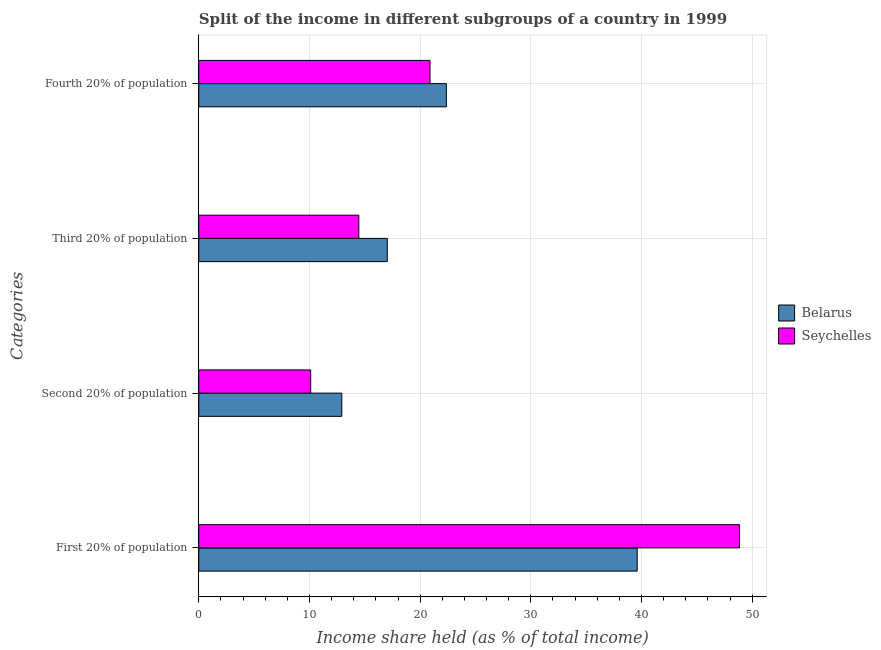Are the number of bars on each tick of the Y-axis equal?
Your response must be concise. Yes. How many bars are there on the 2nd tick from the bottom?
Give a very brief answer. 2. What is the label of the 1st group of bars from the top?
Give a very brief answer. Fourth 20% of population. What is the share of the income held by second 20% of the population in Belarus?
Offer a very short reply. 12.92. Across all countries, what is the maximum share of the income held by fourth 20% of the population?
Your answer should be very brief. 22.37. Across all countries, what is the minimum share of the income held by third 20% of the population?
Your response must be concise. 14.46. In which country was the share of the income held by first 20% of the population maximum?
Make the answer very short. Seychelles. In which country was the share of the income held by first 20% of the population minimum?
Ensure brevity in your answer.  Belarus. What is the total share of the income held by first 20% of the population in the graph?
Offer a terse response. 88.47. What is the difference between the share of the income held by second 20% of the population in Seychelles and that in Belarus?
Give a very brief answer. -2.81. What is the difference between the share of the income held by second 20% of the population in Seychelles and the share of the income held by third 20% of the population in Belarus?
Your answer should be very brief. -6.92. What is the average share of the income held by fourth 20% of the population per country?
Offer a very short reply. 21.63. What is the difference between the share of the income held by first 20% of the population and share of the income held by third 20% of the population in Seychelles?
Your response must be concise. 34.4. What is the ratio of the share of the income held by fourth 20% of the population in Seychelles to that in Belarus?
Ensure brevity in your answer.  0.93. Is the share of the income held by third 20% of the population in Belarus less than that in Seychelles?
Make the answer very short. No. Is the difference between the share of the income held by third 20% of the population in Belarus and Seychelles greater than the difference between the share of the income held by fourth 20% of the population in Belarus and Seychelles?
Provide a short and direct response. Yes. What is the difference between the highest and the second highest share of the income held by third 20% of the population?
Your answer should be compact. 2.57. What is the difference between the highest and the lowest share of the income held by third 20% of the population?
Offer a terse response. 2.57. Is the sum of the share of the income held by fourth 20% of the population in Belarus and Seychelles greater than the maximum share of the income held by third 20% of the population across all countries?
Give a very brief answer. Yes. Is it the case that in every country, the sum of the share of the income held by fourth 20% of the population and share of the income held by first 20% of the population is greater than the sum of share of the income held by second 20% of the population and share of the income held by third 20% of the population?
Offer a very short reply. Yes. What does the 1st bar from the top in First 20% of population represents?
Your answer should be compact. Seychelles. What does the 2nd bar from the bottom in Third 20% of population represents?
Provide a short and direct response. Seychelles. Where does the legend appear in the graph?
Make the answer very short. Center right. How many legend labels are there?
Offer a terse response. 2. What is the title of the graph?
Provide a succinct answer. Split of the income in different subgroups of a country in 1999. Does "Tuvalu" appear as one of the legend labels in the graph?
Offer a very short reply. No. What is the label or title of the X-axis?
Make the answer very short. Income share held (as % of total income). What is the label or title of the Y-axis?
Keep it short and to the point. Categories. What is the Income share held (as % of total income) in Belarus in First 20% of population?
Keep it short and to the point. 39.61. What is the Income share held (as % of total income) in Seychelles in First 20% of population?
Provide a short and direct response. 48.86. What is the Income share held (as % of total income) in Belarus in Second 20% of population?
Offer a terse response. 12.92. What is the Income share held (as % of total income) of Seychelles in Second 20% of population?
Your response must be concise. 10.11. What is the Income share held (as % of total income) of Belarus in Third 20% of population?
Provide a short and direct response. 17.03. What is the Income share held (as % of total income) in Seychelles in Third 20% of population?
Ensure brevity in your answer.  14.46. What is the Income share held (as % of total income) of Belarus in Fourth 20% of population?
Provide a short and direct response. 22.37. What is the Income share held (as % of total income) of Seychelles in Fourth 20% of population?
Your answer should be very brief. 20.89. Across all Categories, what is the maximum Income share held (as % of total income) in Belarus?
Your response must be concise. 39.61. Across all Categories, what is the maximum Income share held (as % of total income) in Seychelles?
Make the answer very short. 48.86. Across all Categories, what is the minimum Income share held (as % of total income) of Belarus?
Your response must be concise. 12.92. Across all Categories, what is the minimum Income share held (as % of total income) in Seychelles?
Provide a short and direct response. 10.11. What is the total Income share held (as % of total income) of Belarus in the graph?
Make the answer very short. 91.93. What is the total Income share held (as % of total income) in Seychelles in the graph?
Keep it short and to the point. 94.32. What is the difference between the Income share held (as % of total income) in Belarus in First 20% of population and that in Second 20% of population?
Your answer should be very brief. 26.69. What is the difference between the Income share held (as % of total income) in Seychelles in First 20% of population and that in Second 20% of population?
Give a very brief answer. 38.75. What is the difference between the Income share held (as % of total income) of Belarus in First 20% of population and that in Third 20% of population?
Make the answer very short. 22.58. What is the difference between the Income share held (as % of total income) of Seychelles in First 20% of population and that in Third 20% of population?
Offer a very short reply. 34.4. What is the difference between the Income share held (as % of total income) of Belarus in First 20% of population and that in Fourth 20% of population?
Provide a succinct answer. 17.24. What is the difference between the Income share held (as % of total income) of Seychelles in First 20% of population and that in Fourth 20% of population?
Ensure brevity in your answer.  27.97. What is the difference between the Income share held (as % of total income) of Belarus in Second 20% of population and that in Third 20% of population?
Provide a short and direct response. -4.11. What is the difference between the Income share held (as % of total income) in Seychelles in Second 20% of population and that in Third 20% of population?
Provide a short and direct response. -4.35. What is the difference between the Income share held (as % of total income) of Belarus in Second 20% of population and that in Fourth 20% of population?
Your response must be concise. -9.45. What is the difference between the Income share held (as % of total income) of Seychelles in Second 20% of population and that in Fourth 20% of population?
Ensure brevity in your answer.  -10.78. What is the difference between the Income share held (as % of total income) of Belarus in Third 20% of population and that in Fourth 20% of population?
Make the answer very short. -5.34. What is the difference between the Income share held (as % of total income) of Seychelles in Third 20% of population and that in Fourth 20% of population?
Provide a short and direct response. -6.43. What is the difference between the Income share held (as % of total income) in Belarus in First 20% of population and the Income share held (as % of total income) in Seychelles in Second 20% of population?
Provide a succinct answer. 29.5. What is the difference between the Income share held (as % of total income) of Belarus in First 20% of population and the Income share held (as % of total income) of Seychelles in Third 20% of population?
Your answer should be compact. 25.15. What is the difference between the Income share held (as % of total income) in Belarus in First 20% of population and the Income share held (as % of total income) in Seychelles in Fourth 20% of population?
Give a very brief answer. 18.72. What is the difference between the Income share held (as % of total income) in Belarus in Second 20% of population and the Income share held (as % of total income) in Seychelles in Third 20% of population?
Offer a very short reply. -1.54. What is the difference between the Income share held (as % of total income) in Belarus in Second 20% of population and the Income share held (as % of total income) in Seychelles in Fourth 20% of population?
Your answer should be compact. -7.97. What is the difference between the Income share held (as % of total income) of Belarus in Third 20% of population and the Income share held (as % of total income) of Seychelles in Fourth 20% of population?
Your answer should be very brief. -3.86. What is the average Income share held (as % of total income) in Belarus per Categories?
Offer a terse response. 22.98. What is the average Income share held (as % of total income) of Seychelles per Categories?
Keep it short and to the point. 23.58. What is the difference between the Income share held (as % of total income) of Belarus and Income share held (as % of total income) of Seychelles in First 20% of population?
Keep it short and to the point. -9.25. What is the difference between the Income share held (as % of total income) of Belarus and Income share held (as % of total income) of Seychelles in Second 20% of population?
Make the answer very short. 2.81. What is the difference between the Income share held (as % of total income) in Belarus and Income share held (as % of total income) in Seychelles in Third 20% of population?
Provide a short and direct response. 2.57. What is the difference between the Income share held (as % of total income) of Belarus and Income share held (as % of total income) of Seychelles in Fourth 20% of population?
Provide a succinct answer. 1.48. What is the ratio of the Income share held (as % of total income) of Belarus in First 20% of population to that in Second 20% of population?
Your answer should be compact. 3.07. What is the ratio of the Income share held (as % of total income) in Seychelles in First 20% of population to that in Second 20% of population?
Offer a very short reply. 4.83. What is the ratio of the Income share held (as % of total income) of Belarus in First 20% of population to that in Third 20% of population?
Your answer should be compact. 2.33. What is the ratio of the Income share held (as % of total income) of Seychelles in First 20% of population to that in Third 20% of population?
Offer a very short reply. 3.38. What is the ratio of the Income share held (as % of total income) in Belarus in First 20% of population to that in Fourth 20% of population?
Offer a very short reply. 1.77. What is the ratio of the Income share held (as % of total income) in Seychelles in First 20% of population to that in Fourth 20% of population?
Offer a terse response. 2.34. What is the ratio of the Income share held (as % of total income) of Belarus in Second 20% of population to that in Third 20% of population?
Your answer should be compact. 0.76. What is the ratio of the Income share held (as % of total income) of Seychelles in Second 20% of population to that in Third 20% of population?
Provide a short and direct response. 0.7. What is the ratio of the Income share held (as % of total income) of Belarus in Second 20% of population to that in Fourth 20% of population?
Offer a terse response. 0.58. What is the ratio of the Income share held (as % of total income) in Seychelles in Second 20% of population to that in Fourth 20% of population?
Give a very brief answer. 0.48. What is the ratio of the Income share held (as % of total income) of Belarus in Third 20% of population to that in Fourth 20% of population?
Provide a succinct answer. 0.76. What is the ratio of the Income share held (as % of total income) in Seychelles in Third 20% of population to that in Fourth 20% of population?
Give a very brief answer. 0.69. What is the difference between the highest and the second highest Income share held (as % of total income) in Belarus?
Offer a very short reply. 17.24. What is the difference between the highest and the second highest Income share held (as % of total income) in Seychelles?
Provide a succinct answer. 27.97. What is the difference between the highest and the lowest Income share held (as % of total income) in Belarus?
Your response must be concise. 26.69. What is the difference between the highest and the lowest Income share held (as % of total income) of Seychelles?
Offer a terse response. 38.75. 